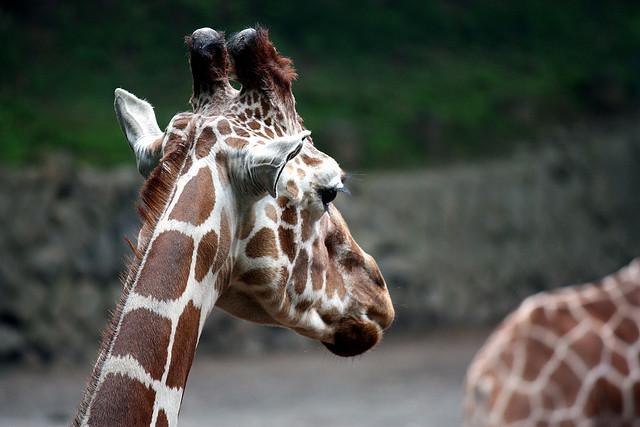Where is the rear end of a Giraffe shown?
Write a very short answer. Right. What is the giraffe looking at?
Answer briefly. Other giraffe. How many years does the giraffe have?
Be succinct. 2. 